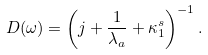<formula> <loc_0><loc_0><loc_500><loc_500>D ( \omega ) = { \left ( j + \frac { 1 } { \lambda _ { a } } + \kappa ^ { s } _ { 1 } \right ) } ^ { - 1 } \, .</formula> 